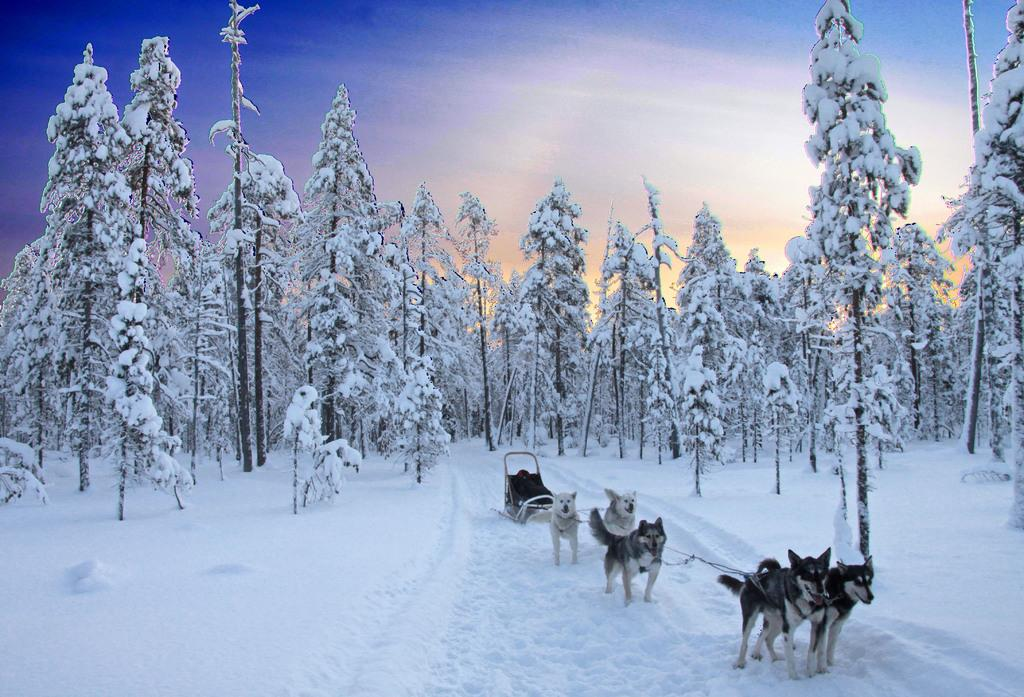What animals are present in the image? There are dogs in the image. What are the dogs doing in the image? The dogs are running in the snow. What type of vegetation can be seen in the image? There are trees in the image. What is visible at the top of the image? The sky is visible at the top of the image and appears to be clear. What type of glass is being used to make the pancake in the image? There is no glass or pancake present in the image; it features dogs running in the snow. What color is the paint on the trees in the image? There is no paint on the trees in the image; they are natural trees with their original colors. 